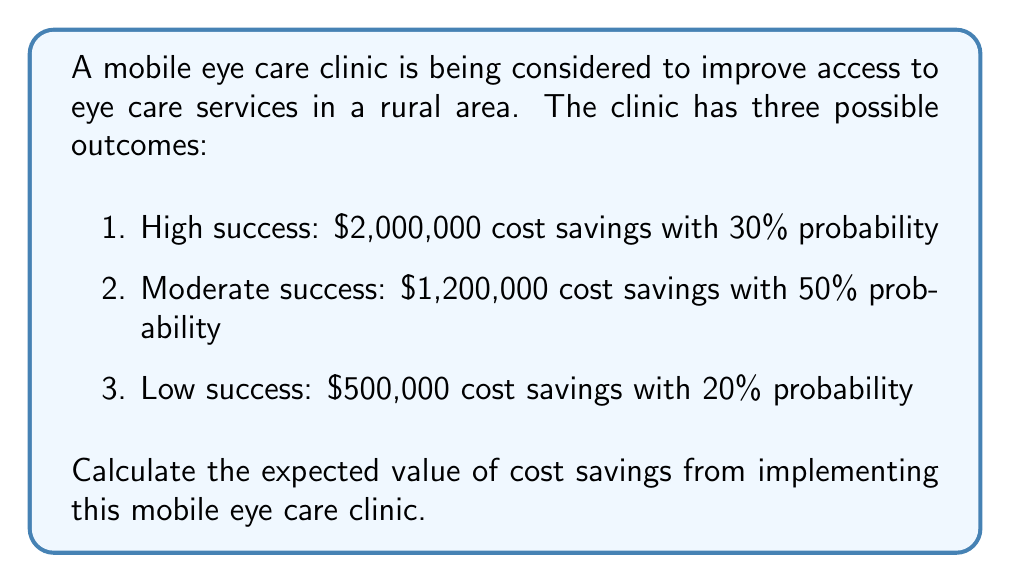What is the answer to this math problem? To calculate the expected value, we need to multiply each possible outcome by its probability and then sum these products. Let's follow these steps:

1. Calculate the value for high success:
   $$2,000,000 \times 0.30 = 600,000$$

2. Calculate the value for moderate success:
   $$1,200,000 \times 0.50 = 600,000$$

3. Calculate the value for low success:
   $$500,000 \times 0.20 = 100,000$$

4. Sum all the calculated values:
   $$600,000 + 600,000 + 100,000 = 1,300,000$$

Therefore, the expected value of cost savings is $1,300,000.

Mathematically, we can express this as:
$$E(X) = \sum_{i=1}^n x_i \cdot p(x_i)$$
Where $x_i$ are the possible outcomes and $p(x_i)$ are their respective probabilities.
Answer: $1,300,000 